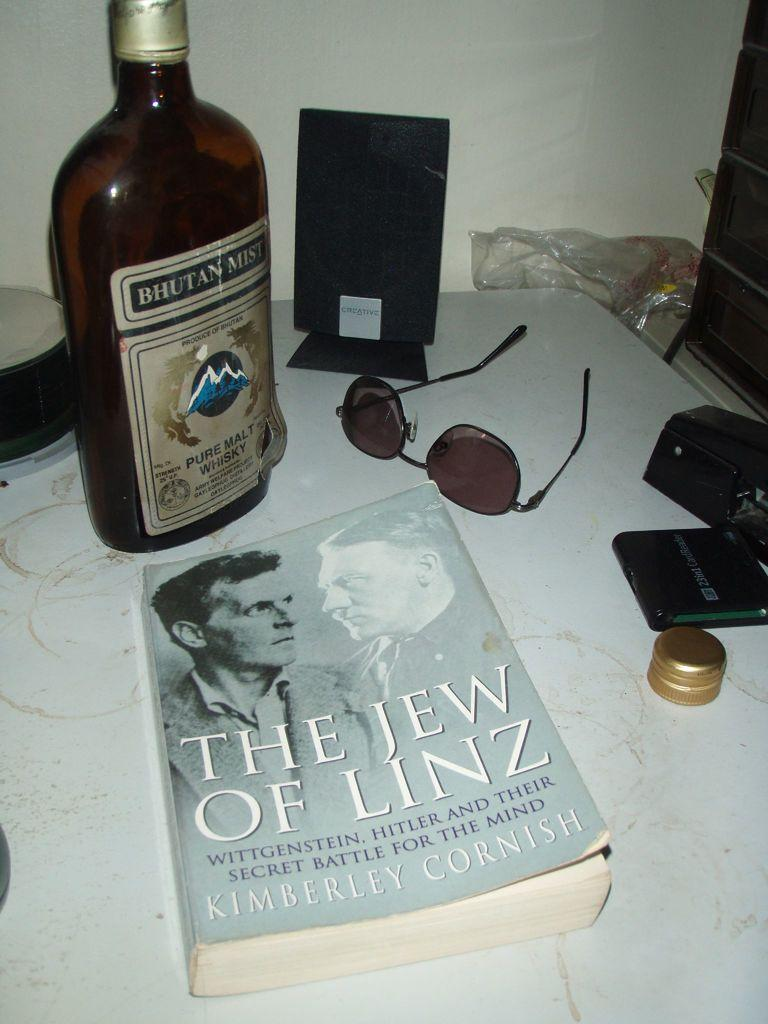What type of furniture is present in the image? There is a table in the image. What items can be seen on the table? There is a book, a pair of spectacles, a bottle, a screen, a box, a cap, and a plastic cover on the table. How does the patch on the table turn the water into wine in the image? There is no patch or water present in the image, and therefore no such transformation can be observed. 